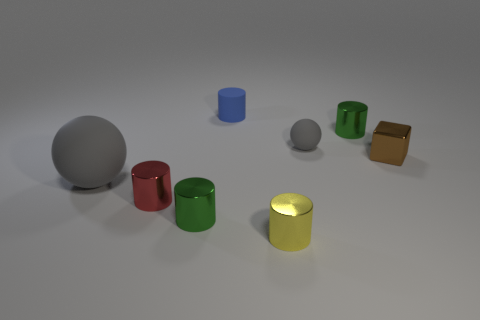Does the gray object left of the small yellow shiny object have the same size as the gray ball that is to the right of the yellow metal cylinder?
Offer a terse response. No. Are there any tiny gray things of the same shape as the small brown metal thing?
Provide a succinct answer. No. Is the number of small gray spheres that are in front of the yellow cylinder less than the number of spheres?
Your response must be concise. Yes. Is the tiny yellow metallic object the same shape as the tiny gray rubber thing?
Your response must be concise. No. What is the size of the green metal cylinder that is behind the tiny red cylinder?
Make the answer very short. Small. The gray sphere that is made of the same material as the small gray object is what size?
Ensure brevity in your answer.  Large. Are there fewer tiny cyan balls than small gray objects?
Your response must be concise. Yes. There is a block that is the same size as the yellow cylinder; what material is it?
Your answer should be compact. Metal. Are there more small metallic cubes than gray matte cylinders?
Make the answer very short. Yes. How many other things are the same color as the big matte ball?
Offer a very short reply. 1. 